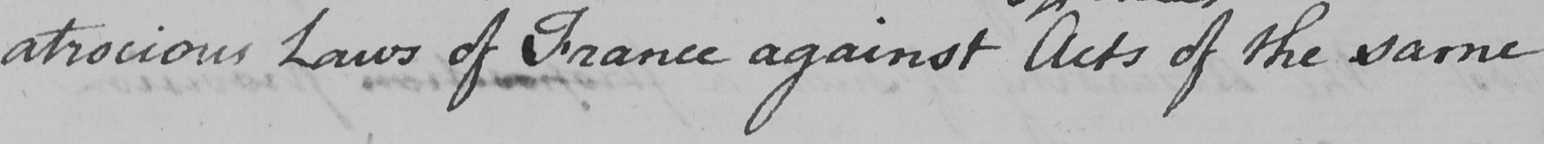What text is written in this handwritten line? atrocious Laws of France against Acts of the same 